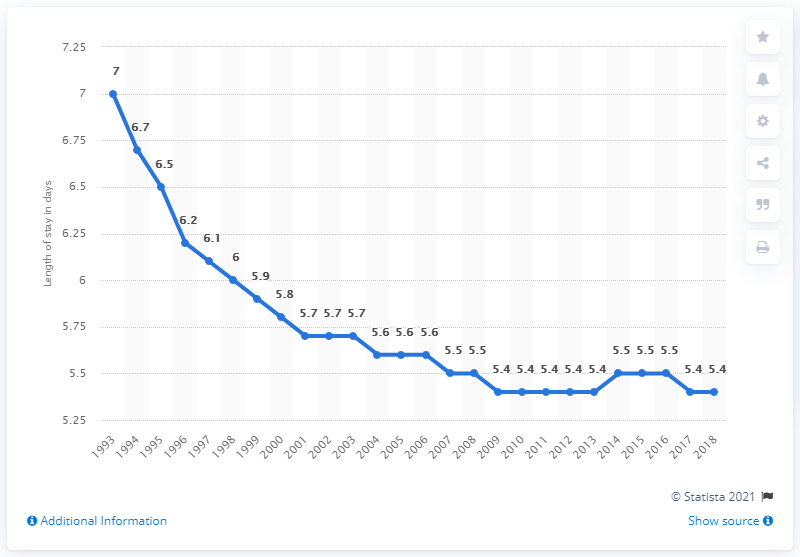Give some essential details in this illustration. In 2007, the average length of a hospital stay in the United States was 5.5 days. 